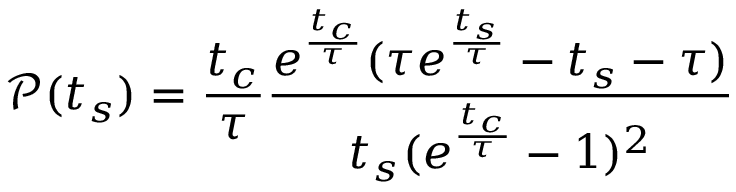Convert formula to latex. <formula><loc_0><loc_0><loc_500><loc_500>\ m a t h s c r { P } ( t _ { s } ) = \frac { t _ { c } } { \tau } \frac { e ^ { \frac { t _ { c } } { \tau } } ( \tau e ^ { \frac { t _ { s } } { \tau } } - t _ { s } - \tau ) } { t _ { s } ( e ^ { \frac { t _ { c } } { \tau } } - 1 ) ^ { 2 } }</formula> 